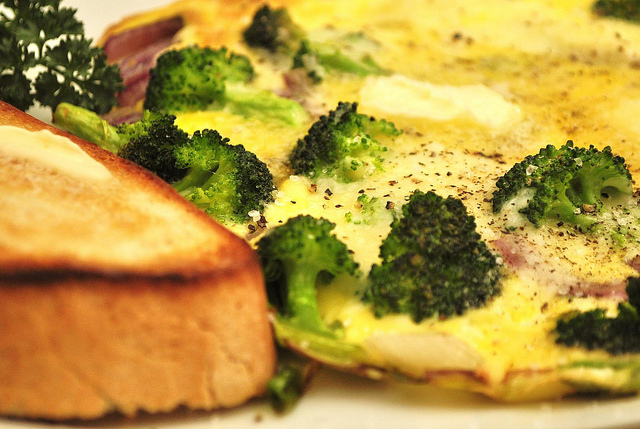<image>Is there a carb-heavy component to this meal? I don't know if there is a carb-heavy component to this meal. It could be both Yes or No. Is there a carb-heavy component to this meal? I don't know if there is a carb-heavy component to this meal. It can be both carb-heavy and not carb-heavy. 